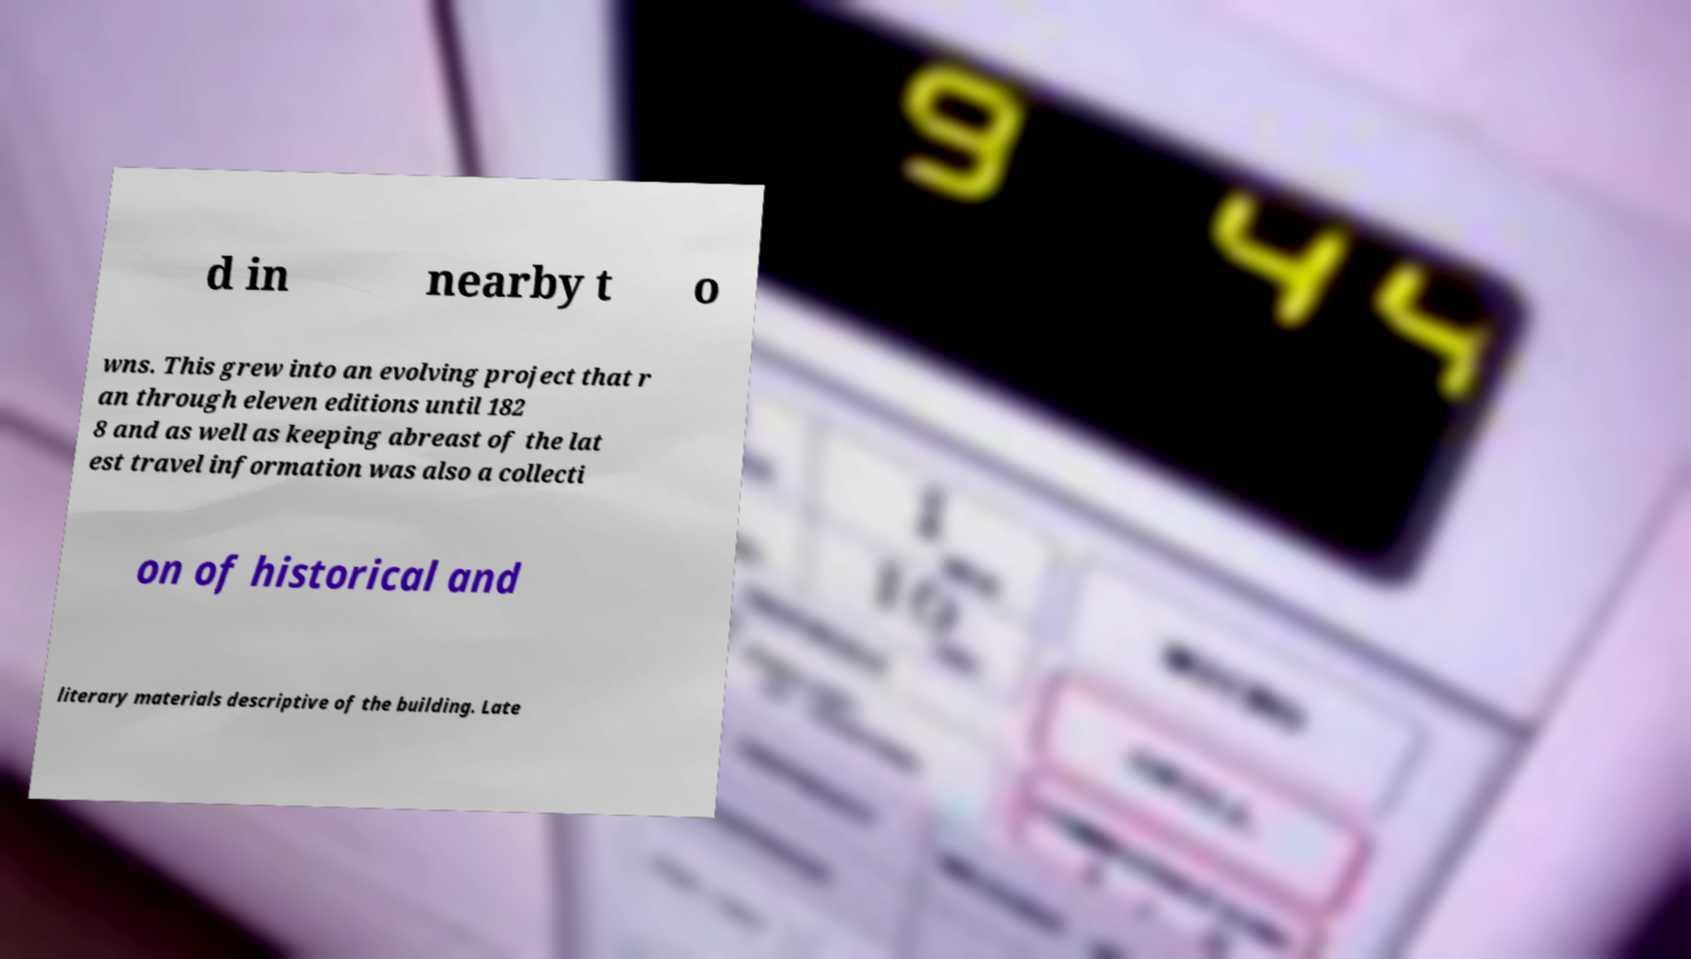Please read and relay the text visible in this image. What does it say? d in nearby t o wns. This grew into an evolving project that r an through eleven editions until 182 8 and as well as keeping abreast of the lat est travel information was also a collecti on of historical and literary materials descriptive of the building. Late 